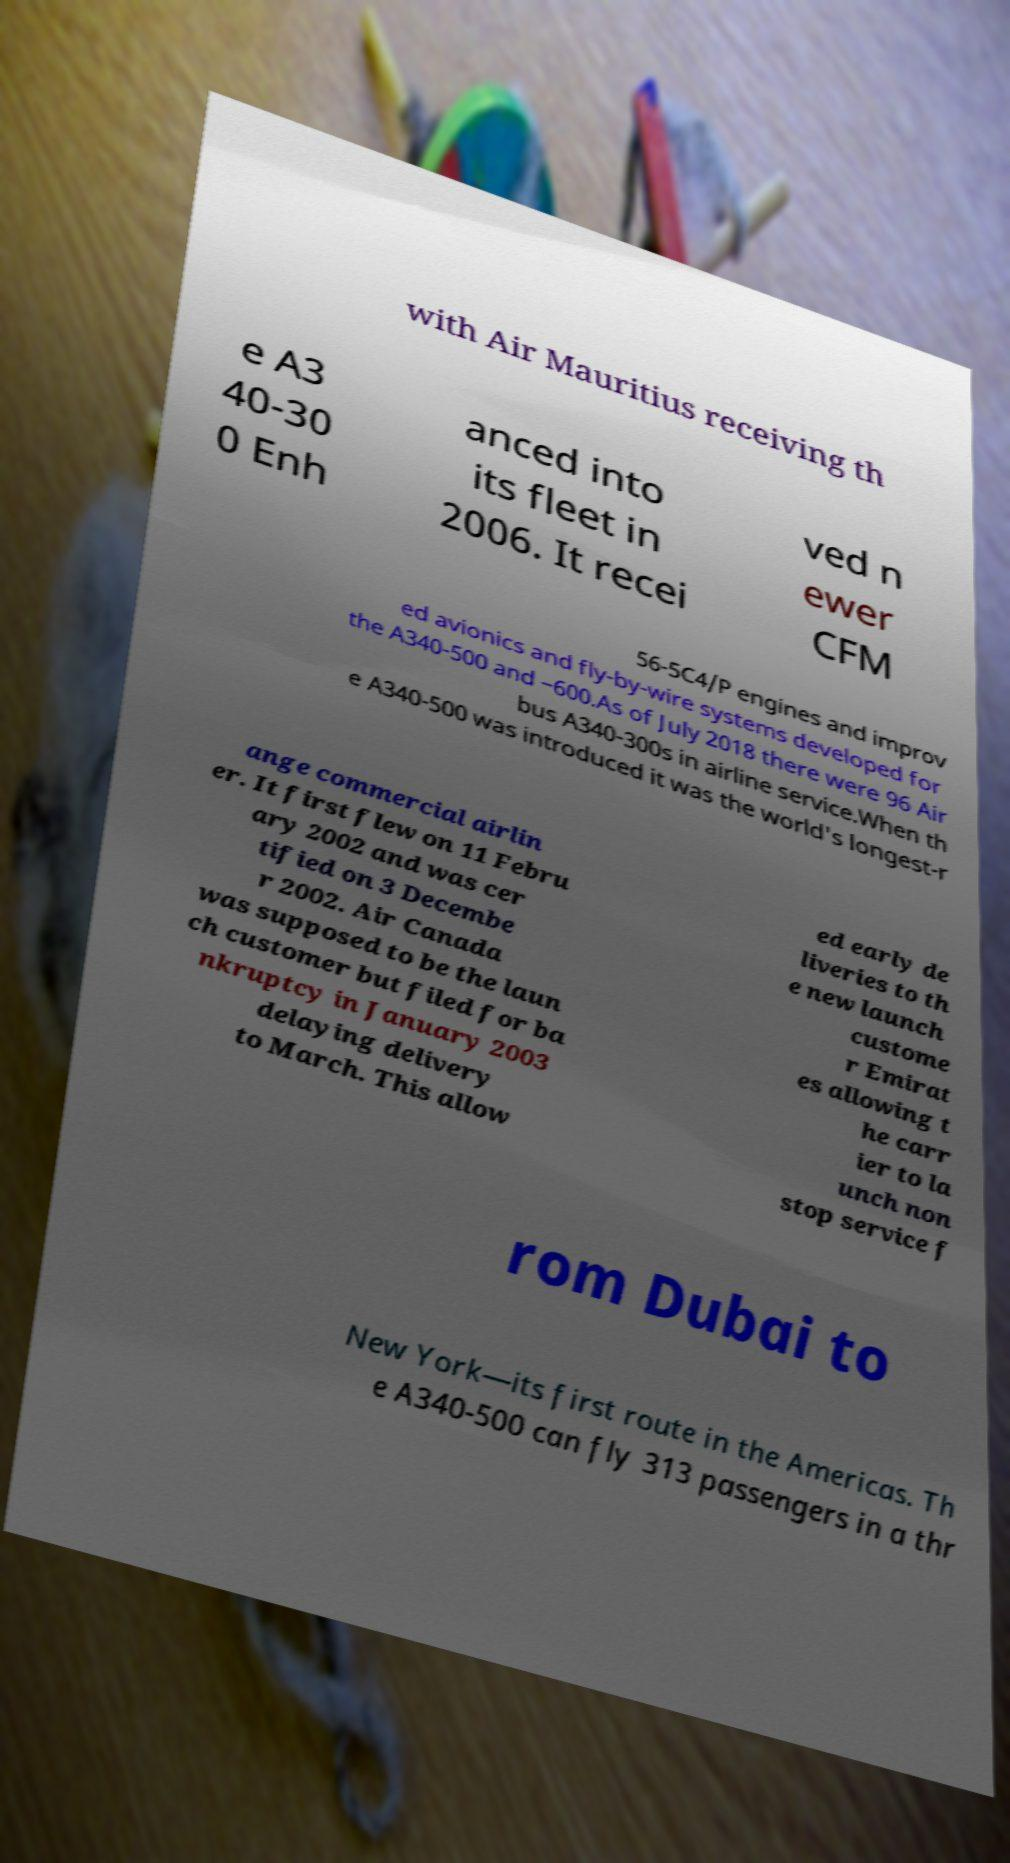Can you accurately transcribe the text from the provided image for me? with Air Mauritius receiving th e A3 40-30 0 Enh anced into its fleet in 2006. It recei ved n ewer CFM 56-5C4/P engines and improv ed avionics and fly-by-wire systems developed for the A340-500 and −600.As of July 2018 there were 96 Air bus A340-300s in airline service.When th e A340-500 was introduced it was the world's longest-r ange commercial airlin er. It first flew on 11 Febru ary 2002 and was cer tified on 3 Decembe r 2002. Air Canada was supposed to be the laun ch customer but filed for ba nkruptcy in January 2003 delaying delivery to March. This allow ed early de liveries to th e new launch custome r Emirat es allowing t he carr ier to la unch non stop service f rom Dubai to New York—its first route in the Americas. Th e A340-500 can fly 313 passengers in a thr 